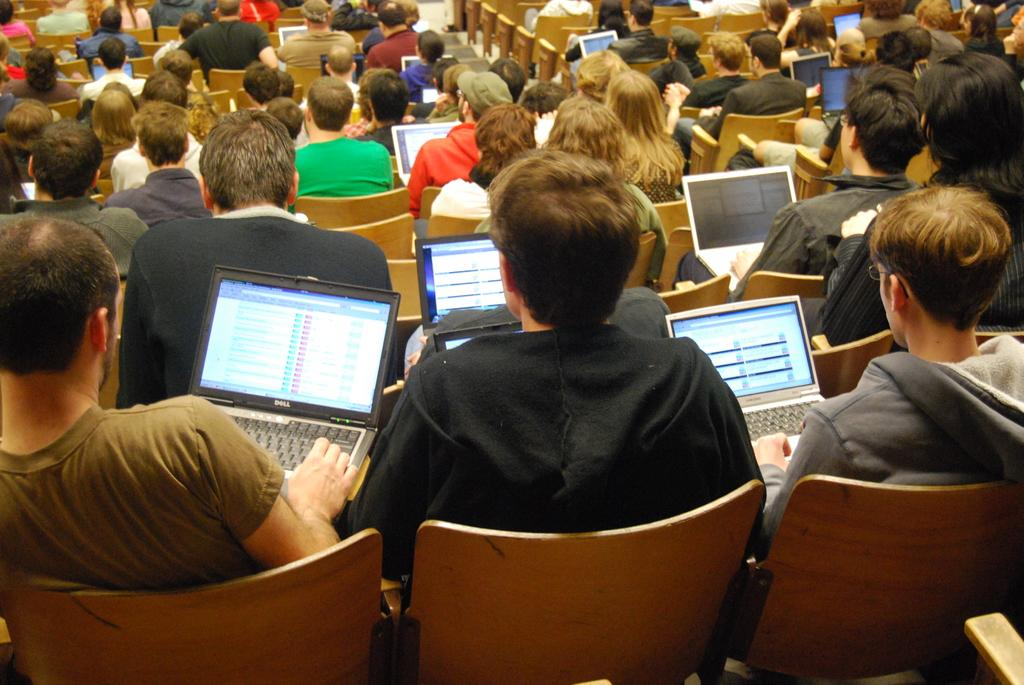What is the main subject of the image? The main subject of the image is a group of people. What are the people in the image doing? The people are sitting on chairs in the image. What electronic devices can be seen in the image? There are laptops visible in the image. What type of loaf is being served to the people in the image? There is no loaf present in the image; the people are sitting on chairs and using laptops. What effect does the presence of the laptops have on the people in the image? The presence of laptops does not have a specific effect on the people in the image, as we cannot determine their emotional state or reactions from the image alone. 